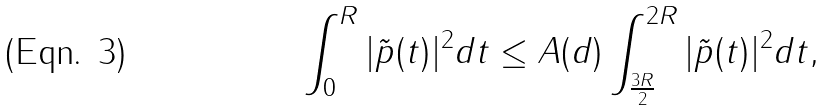<formula> <loc_0><loc_0><loc_500><loc_500>\int _ { 0 } ^ { R } | \tilde { p } ( t ) | ^ { 2 } d t \leq A ( d ) \int _ { \frac { 3 R } { 2 } } ^ { 2 R } | \tilde { p } ( t ) | ^ { 2 } d t ,</formula> 